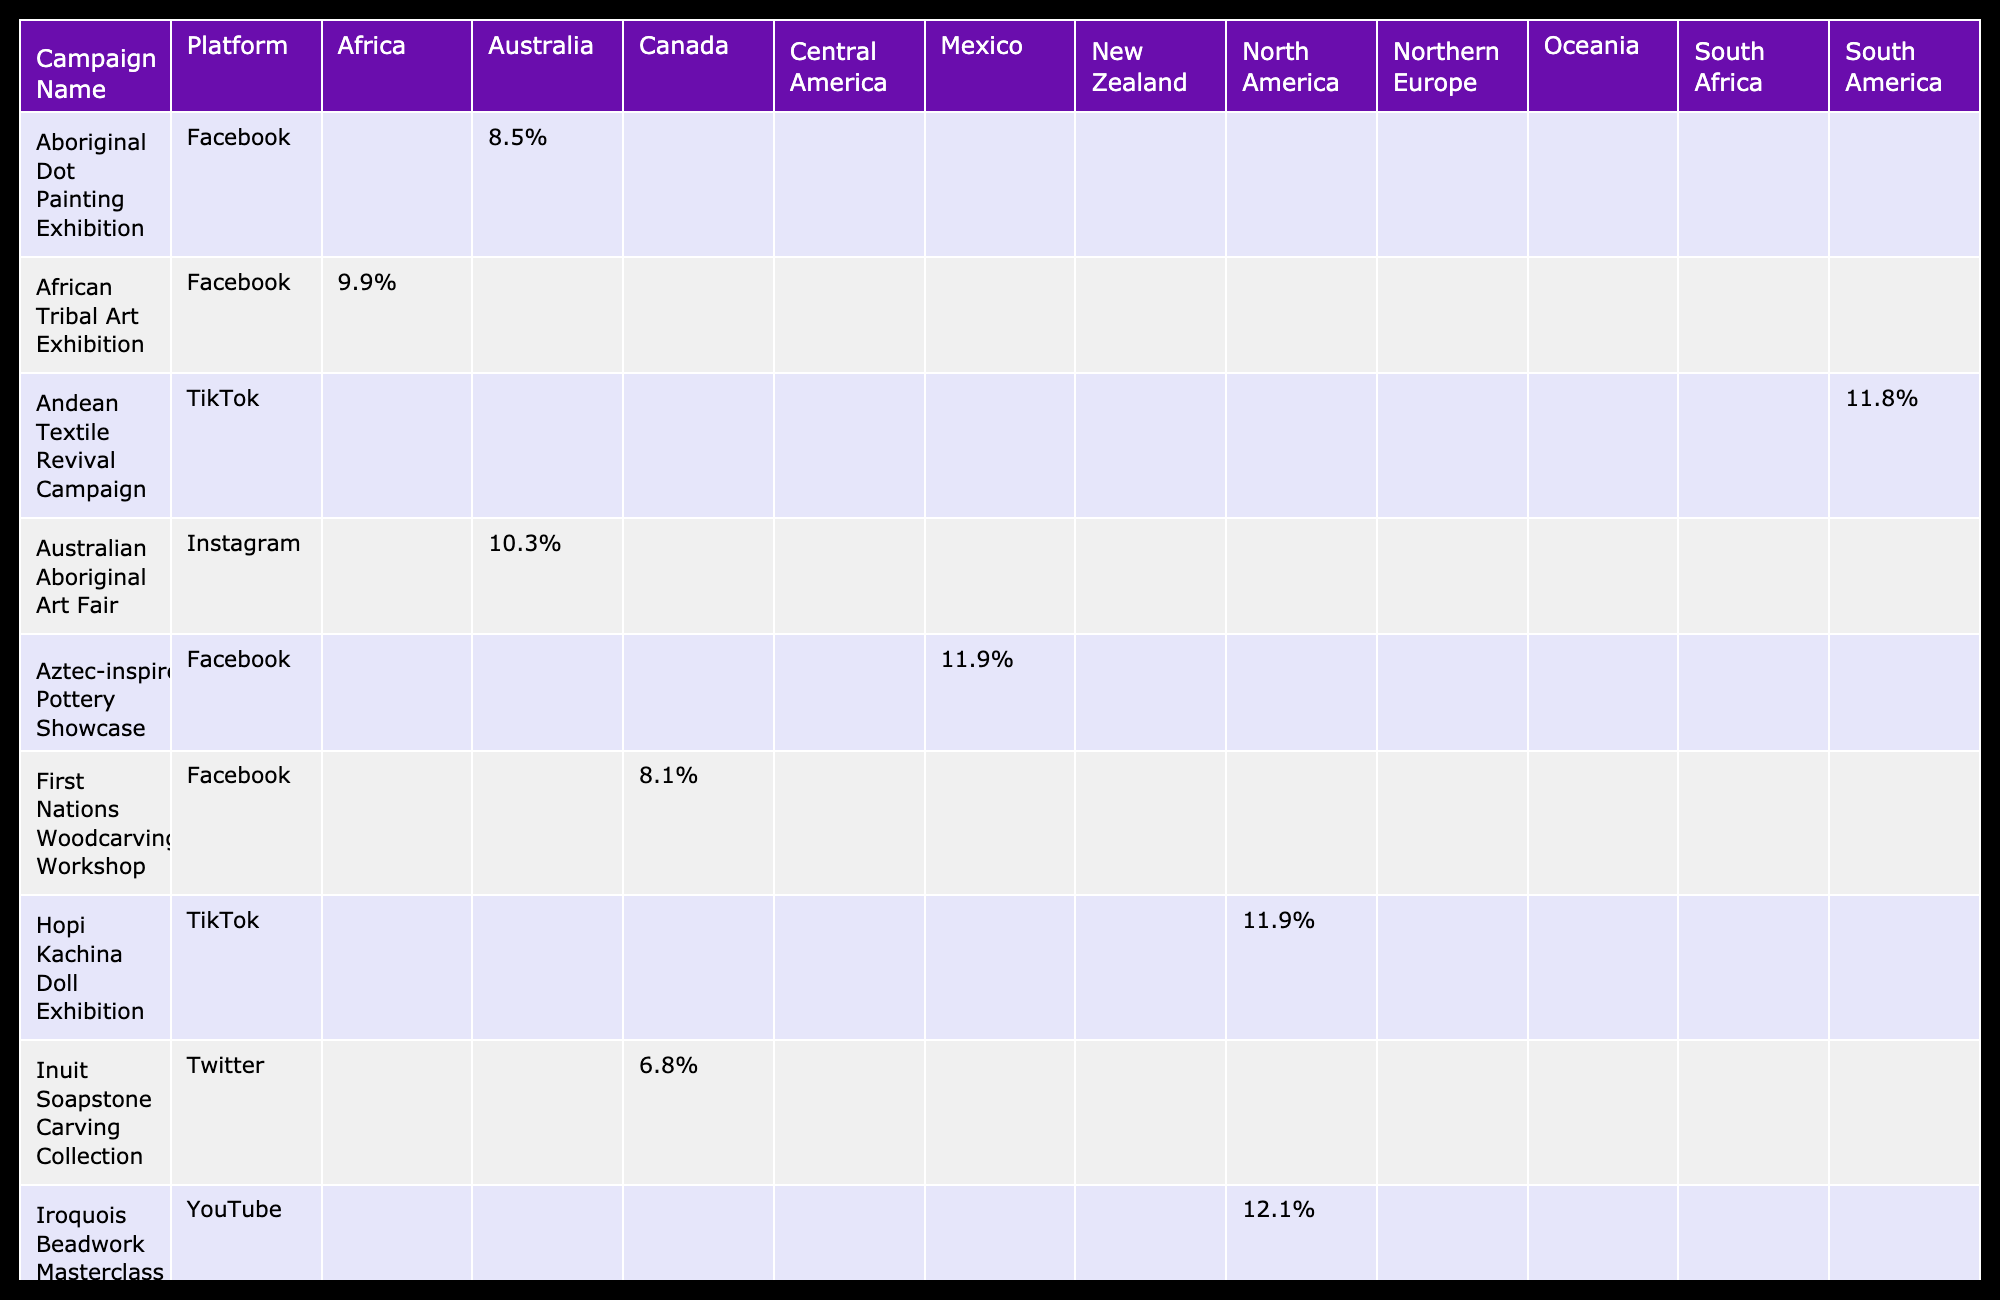What is the engagement rate of the Navajo Weaving Showcase campaign on Instagram? The table shows that the engagement rate for the Navajo Weaving Showcase campaign on Instagram is 7.2%.
Answer: 7.2% Which campaign on Facebook has the highest engagement rate? Looking through the Facebook campaigns in the table, the Aboriginal Dot Painting Exhibition has the highest engagement rate of 8.5%.
Answer: 8.5% How many campaigns in North America have an engagement rate above 10%? By checking the engagement rates for the campaigns in North America, the Native American Dreamcatcher Sale (12.2%), Maori Greenstone Jewelry Launch (13.7%), and Hopi Kachina Doll Exhibition (11.9%) are above 10%. Therefore, there are three campaigns.
Answer: 3 What is the average engagement rate for campaigns that were promoted on Pinterest? The engagement rates for Pinterest campaigns in the table are 13.7% for Maori Greenstone Jewelry Launch and 11.0% for Polynesian Tapa Cloth Showcase. Calculating the average: (13.7 + 11.0) / 2 = 12.35%.
Answer: 12.4% Is the engagement rate for the Zulu Beadwork Masterclass higher than that for the Iroquois Beadwork Masterclass? The engagement rate for the Zulu Beadwork Masterclass is 12.9%, while for the Iroquois Beadwork Masterclass, it is 12.1%. Since 12.9% is greater than 12.1%, the statement is true.
Answer: Yes What is the total number of likes for campaigns in Australia? The total likes for campaigns in Australia are 3789 for Aboriginal Dot Painting Exhibition and 4567 for Australian Aboriginal Art Fair. Adding them gives 3789 + 4567 = 8356 likes.
Answer: 8356 Which platform has the most campaigns listed in the table? By reviewing the table, Instagram has the most campaigns listed, with a total of four campaigns: Navajo Weaving Showcase, Native American Dreamcatcher Sale, Australian Aboriginal Art Fair, and Hopi Kachina Doll Exhibition.
Answer: Instagram Is the engagement rate of the Maori Greenstone Jewelry Launch campaign higher than 12%? The engagement rate for the Maori Greenstone Jewelry Launch campaign is 13.7%, which is indeed higher than 12%. Therefore, the statement is true.
Answer: Yes 